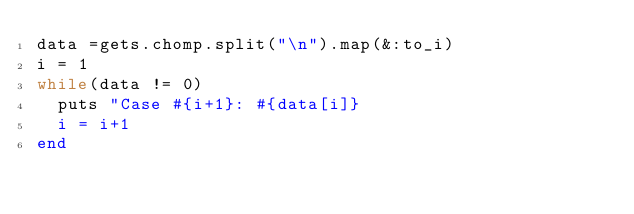Convert code to text. <code><loc_0><loc_0><loc_500><loc_500><_Ruby_>data =gets.chomp.split("\n").map(&:to_i)
i = 1
while(data != 0)
	puts "Case #{i+1}: #{data[i]}
	i = i+1
end</code> 